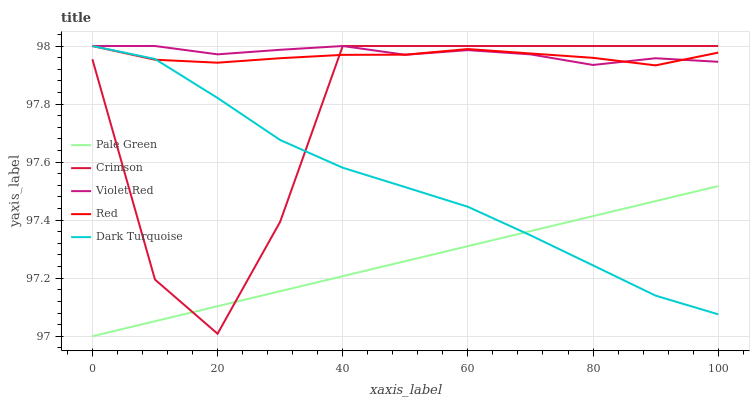Does Dark Turquoise have the minimum area under the curve?
Answer yes or no. No. Does Dark Turquoise have the maximum area under the curve?
Answer yes or no. No. Is Dark Turquoise the smoothest?
Answer yes or no. No. Is Dark Turquoise the roughest?
Answer yes or no. No. Does Dark Turquoise have the lowest value?
Answer yes or no. No. Does Pale Green have the highest value?
Answer yes or no. No. Is Pale Green less than Violet Red?
Answer yes or no. Yes. Is Red greater than Pale Green?
Answer yes or no. Yes. Does Pale Green intersect Violet Red?
Answer yes or no. No. 